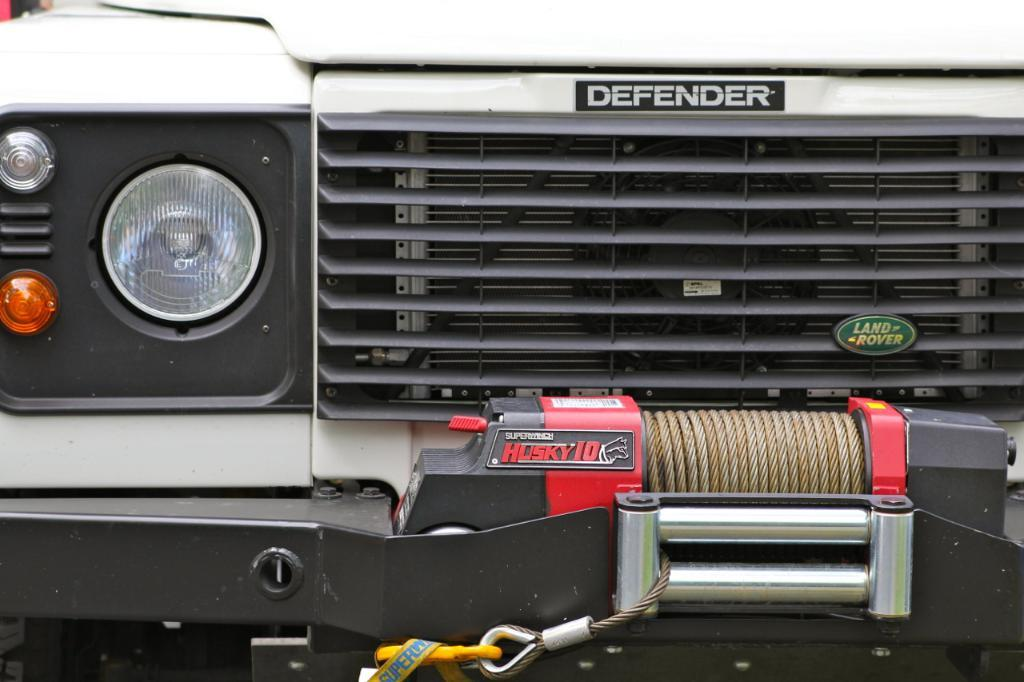What type of vehicle is in the image? There is a vehicle in the image, but the specific type is not mentioned. What is attached to the vehicle? Boards, a rope, and rods are attached to the vehicle. What features can be seen on the vehicle? The vehicle has headlights. Is there any text or information on the boards? Yes, there is writing on the boards. What is the account number of the vehicle in the image? There is no account number associated with the vehicle in the image, as it is not a financial or banking-related object. 